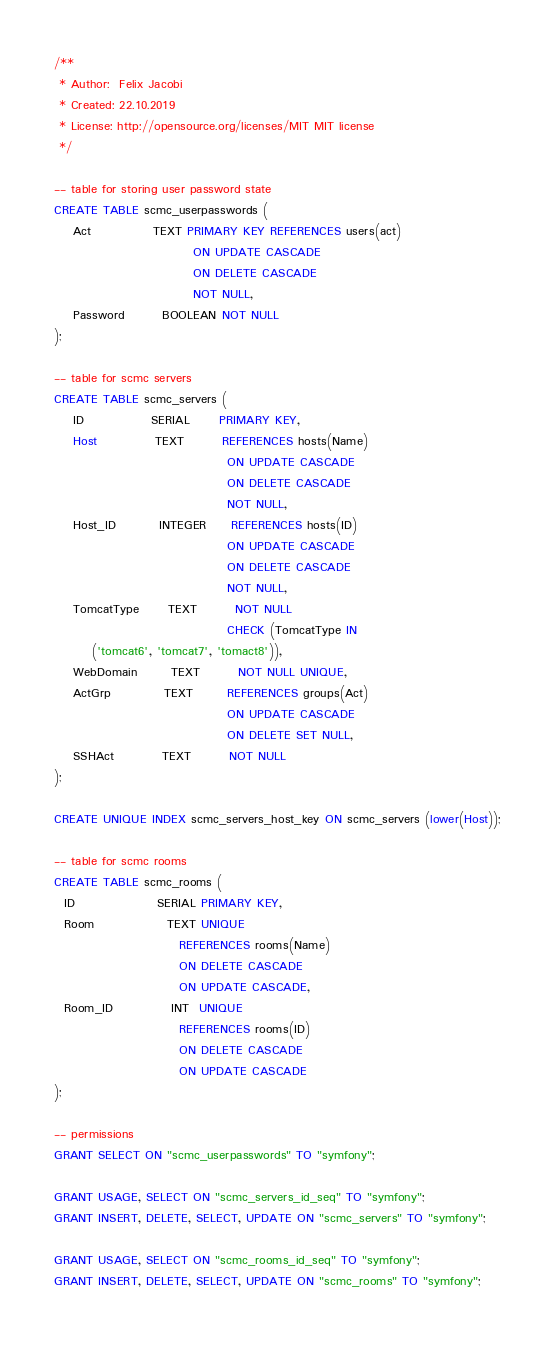<code> <loc_0><loc_0><loc_500><loc_500><_SQL_>/**
 * Author:  Felix Jacobi
 * Created: 22.10.2019
 * License: http://opensource.org/licenses/MIT MIT license
 */

-- table for storing user password state
CREATE TABLE scmc_userpasswords (
    Act             TEXT PRIMARY KEY REFERENCES users(act)
                             ON UPDATE CASCADE
                             ON DELETE CASCADE
                             NOT NULL,
    Password        BOOLEAN NOT NULL
);

-- table for scmc servers
CREATE TABLE scmc_servers (
    ID              SERIAL      PRIMARY KEY,
    Host            TEXT        REFERENCES hosts(Name)
                                    ON UPDATE CASCADE
                                    ON DELETE CASCADE
                                    NOT NULL,
    Host_ID         INTEGER     REFERENCES hosts(ID)
                                    ON UPDATE CASCADE
                                    ON DELETE CASCADE
                                    NOT NULL,
    TomcatType      TEXT        NOT NULL 
                                    CHECK (TomcatType IN
        ('tomcat6', 'tomcat7', 'tomact8')),
    WebDomain       TEXT        NOT NULL UNIQUE,
    ActGrp           TEXT       REFERENCES groups(Act)
                                    ON UPDATE CASCADE
                                    ON DELETE SET NULL,
    SSHAct          TEXT        NOT NULL
);

CREATE UNIQUE INDEX scmc_servers_host_key ON scmc_servers (lower(Host));

-- table for scmc rooms
CREATE TABLE scmc_rooms (
  ID                 SERIAL PRIMARY KEY,
  Room               TEXT UNIQUE
                          REFERENCES rooms(Name)
                          ON DELETE CASCADE
                          ON UPDATE CASCADE,
  Room_ID            INT  UNIQUE
                          REFERENCES rooms(ID)
                          ON DELETE CASCADE
                          ON UPDATE CASCADE
);

-- permissions
GRANT SELECT ON "scmc_userpasswords" TO "symfony";

GRANT USAGE, SELECT ON "scmc_servers_id_seq" TO "symfony";
GRANT INSERT, DELETE, SELECT, UPDATE ON "scmc_servers" TO "symfony";

GRANT USAGE, SELECT ON "scmc_rooms_id_seq" TO "symfony";
GRANT INSERT, DELETE, SELECT, UPDATE ON "scmc_rooms" TO "symfony";
</code> 